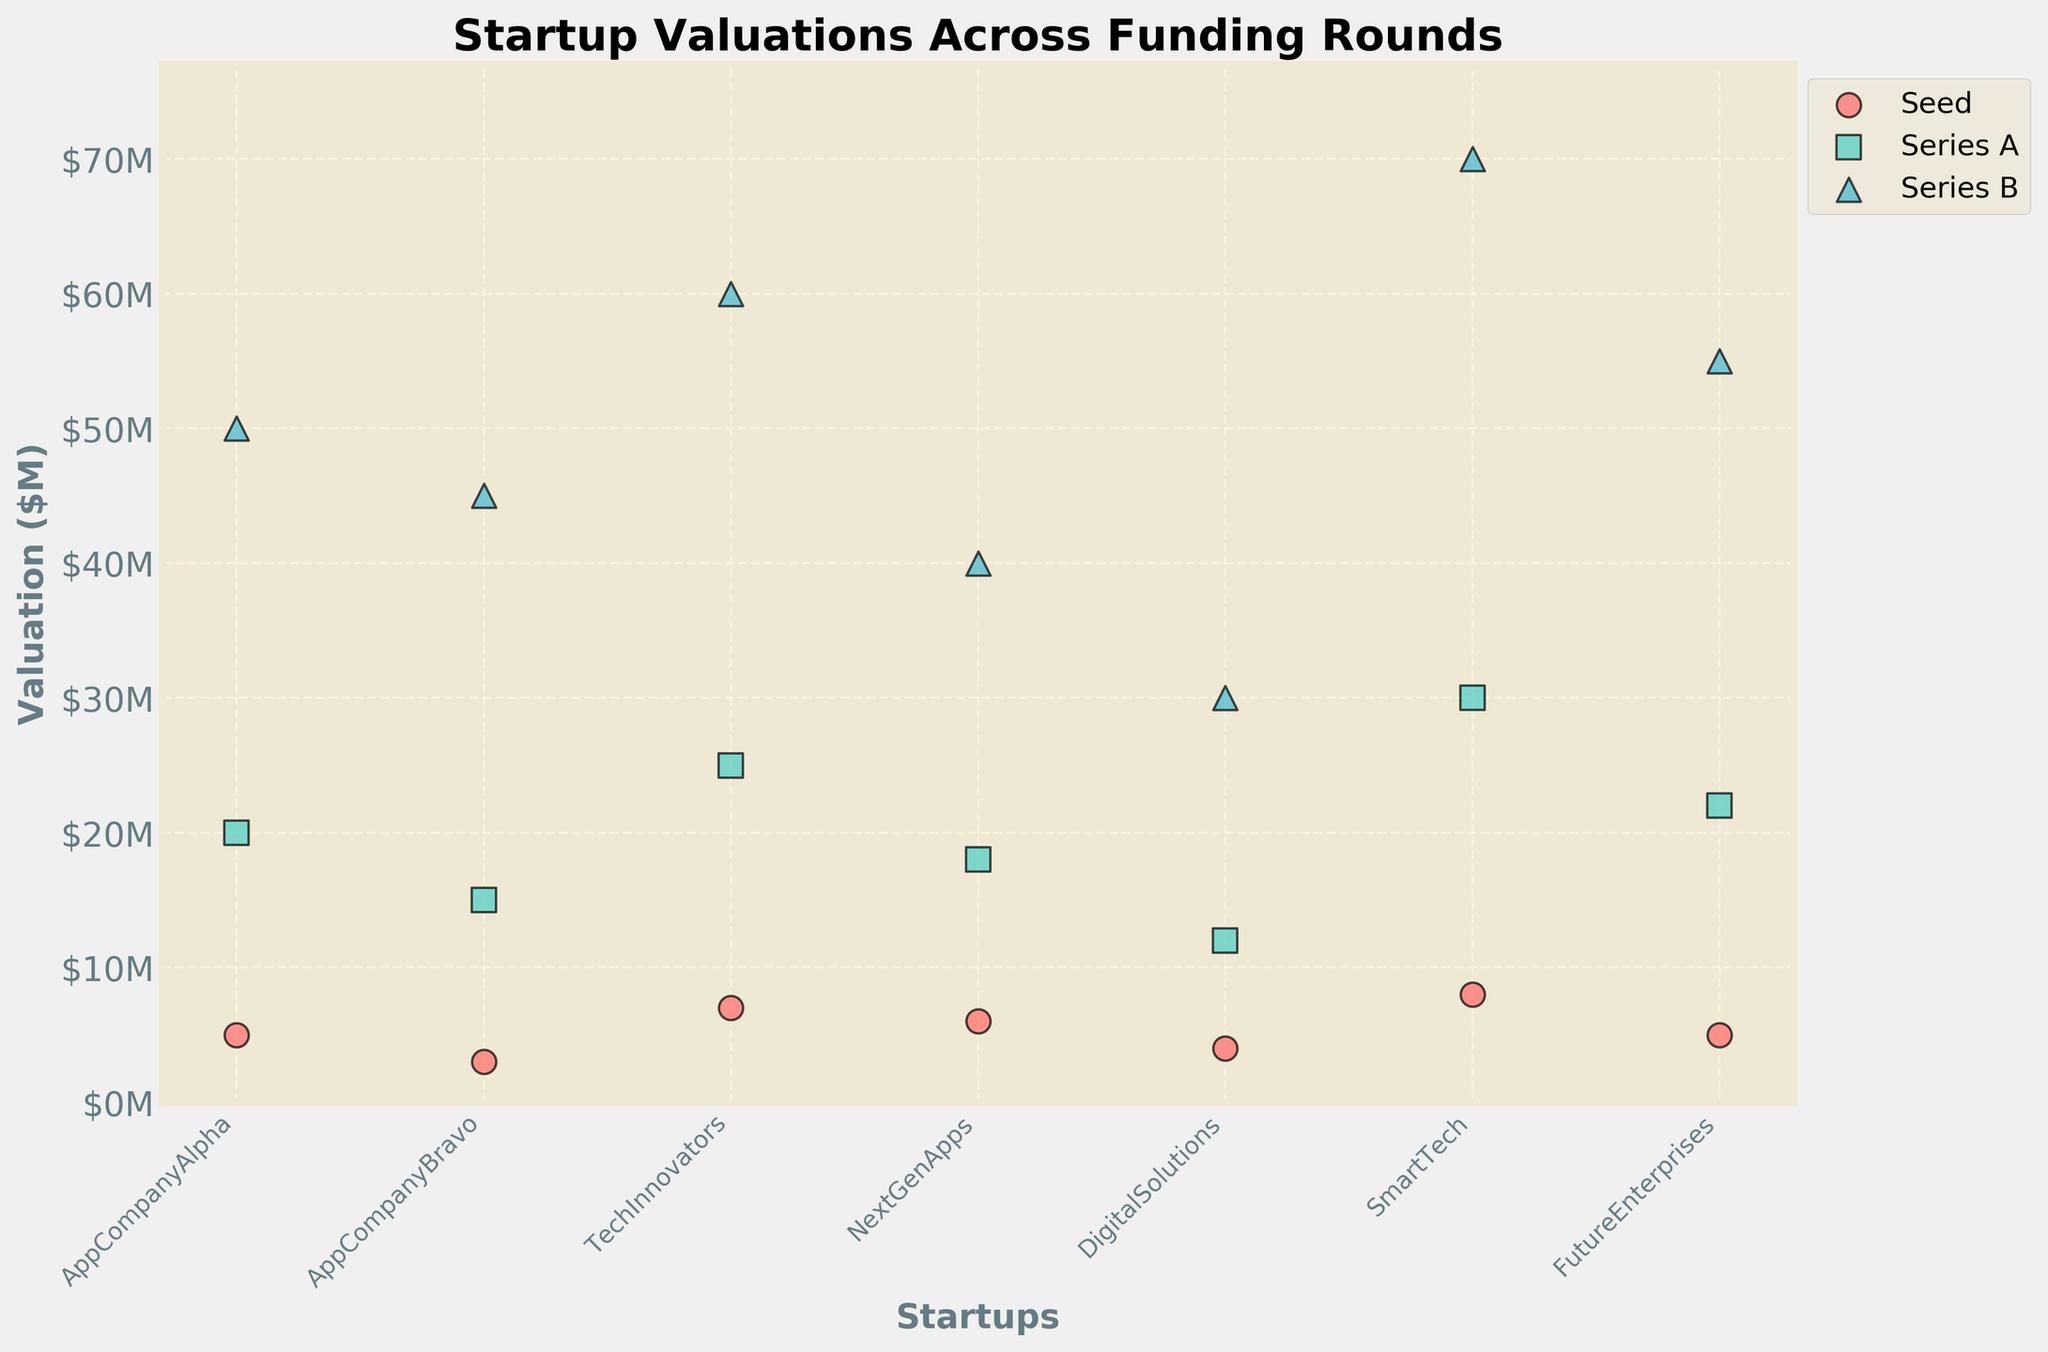Which startup has the highest valuation in Series B? From the figure, look for the highest data point in the Series B group, which has a specific color/marker. The startup is 'SmartTech' with a valuation of $70M.
Answer: SmartTech What is the title of the plot? The large bold text at the top of the figure indicates the title. The title is 'Startup Valuations Across Funding Rounds'.
Answer: Startup Valuations Across Funding Rounds How does the valuation of AppCompanyBravo change from Seed to Series B? Trace the data points for AppCompanyBravo from Seed to Series B. The valuations are $3M in Seed, $15M in Series A, and $45M in Series B, indicating an increasing trend.
Answer: Increasing trend Which startup has the lowest valuation in Series A? Identify the lowest point within the Series A group by the respective marker. 'DigitalSolutions' has the lowest valuation at $12M.
Answer: DigitalSolutions How many funding rounds are depicted in the plot? Count the distinct markers/legends representing different funding rounds. There are three funding rounds depicted: Seed, Series A, and Series B.
Answer: Three Is the valuation of TechInnovators higher or lower than FutureEnterprises in Series B? Compare the Series B valuations of TechInnovators ($60M) and FutureEnterprises ($55M). TechInnovators has a higher valuation.
Answer: Higher What's the average valuation of NextGenApps across all funding rounds? Sum the valuations across all rounds for NextGenApps: $6M (Seed) + $18M (Series A) + $40M (Series B) = $64M. Averaging these over 3 rounds: $64M / 3 = approx. $21.33M.
Answer: $21.33M Which startups have the same valuation in the Seed round? Identify any overlapping data points within the Seed round group. 'AppCompanyAlpha' and 'FutureEnterprises' both have a valuation of $5M.
Answer: AppCompanyAlpha and FutureEnterprises 